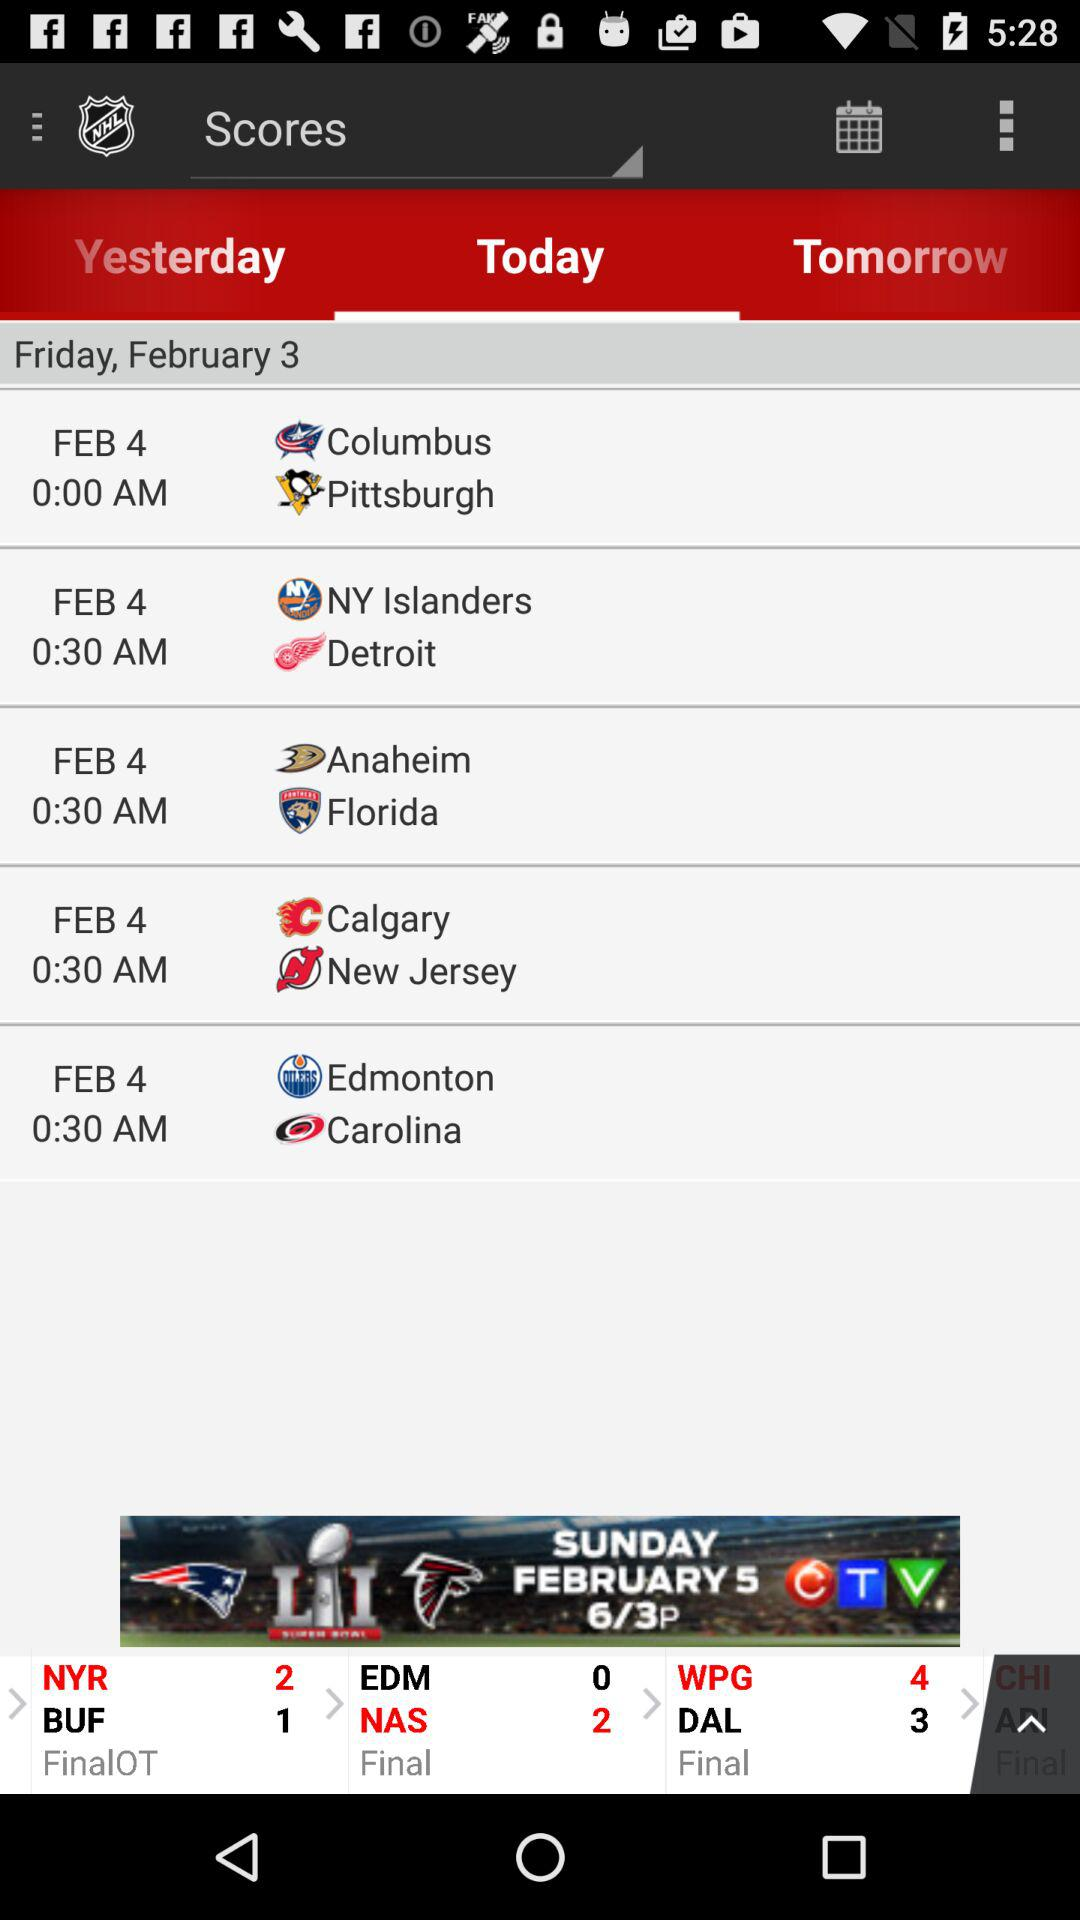What is the time of the match between Columbus and Pittsburgh? The time of the match is 0:00 AM. 